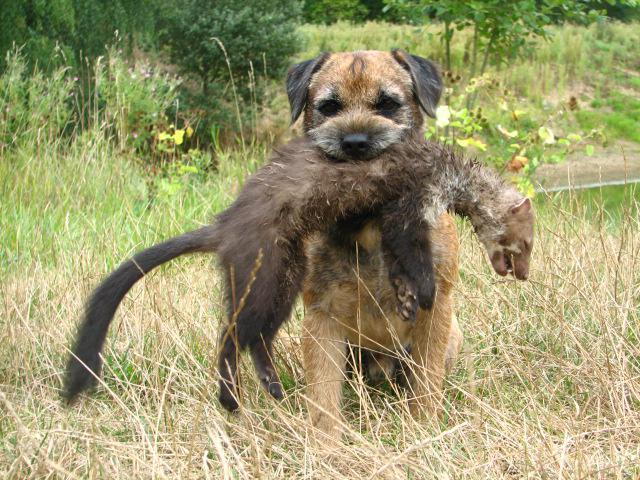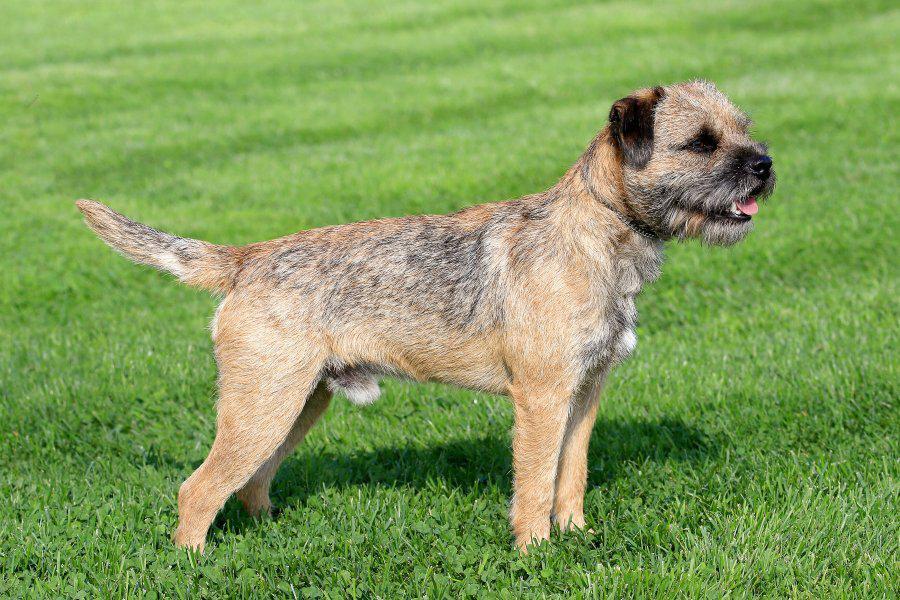The first image is the image on the left, the second image is the image on the right. Given the left and right images, does the statement "a dog is carrying a dead animal in it's mouth" hold true? Answer yes or no. Yes. The first image is the image on the left, the second image is the image on the right. Assess this claim about the two images: "One of the pictures has a dog carrying another animal in its mouth.". Correct or not? Answer yes or no. Yes. 